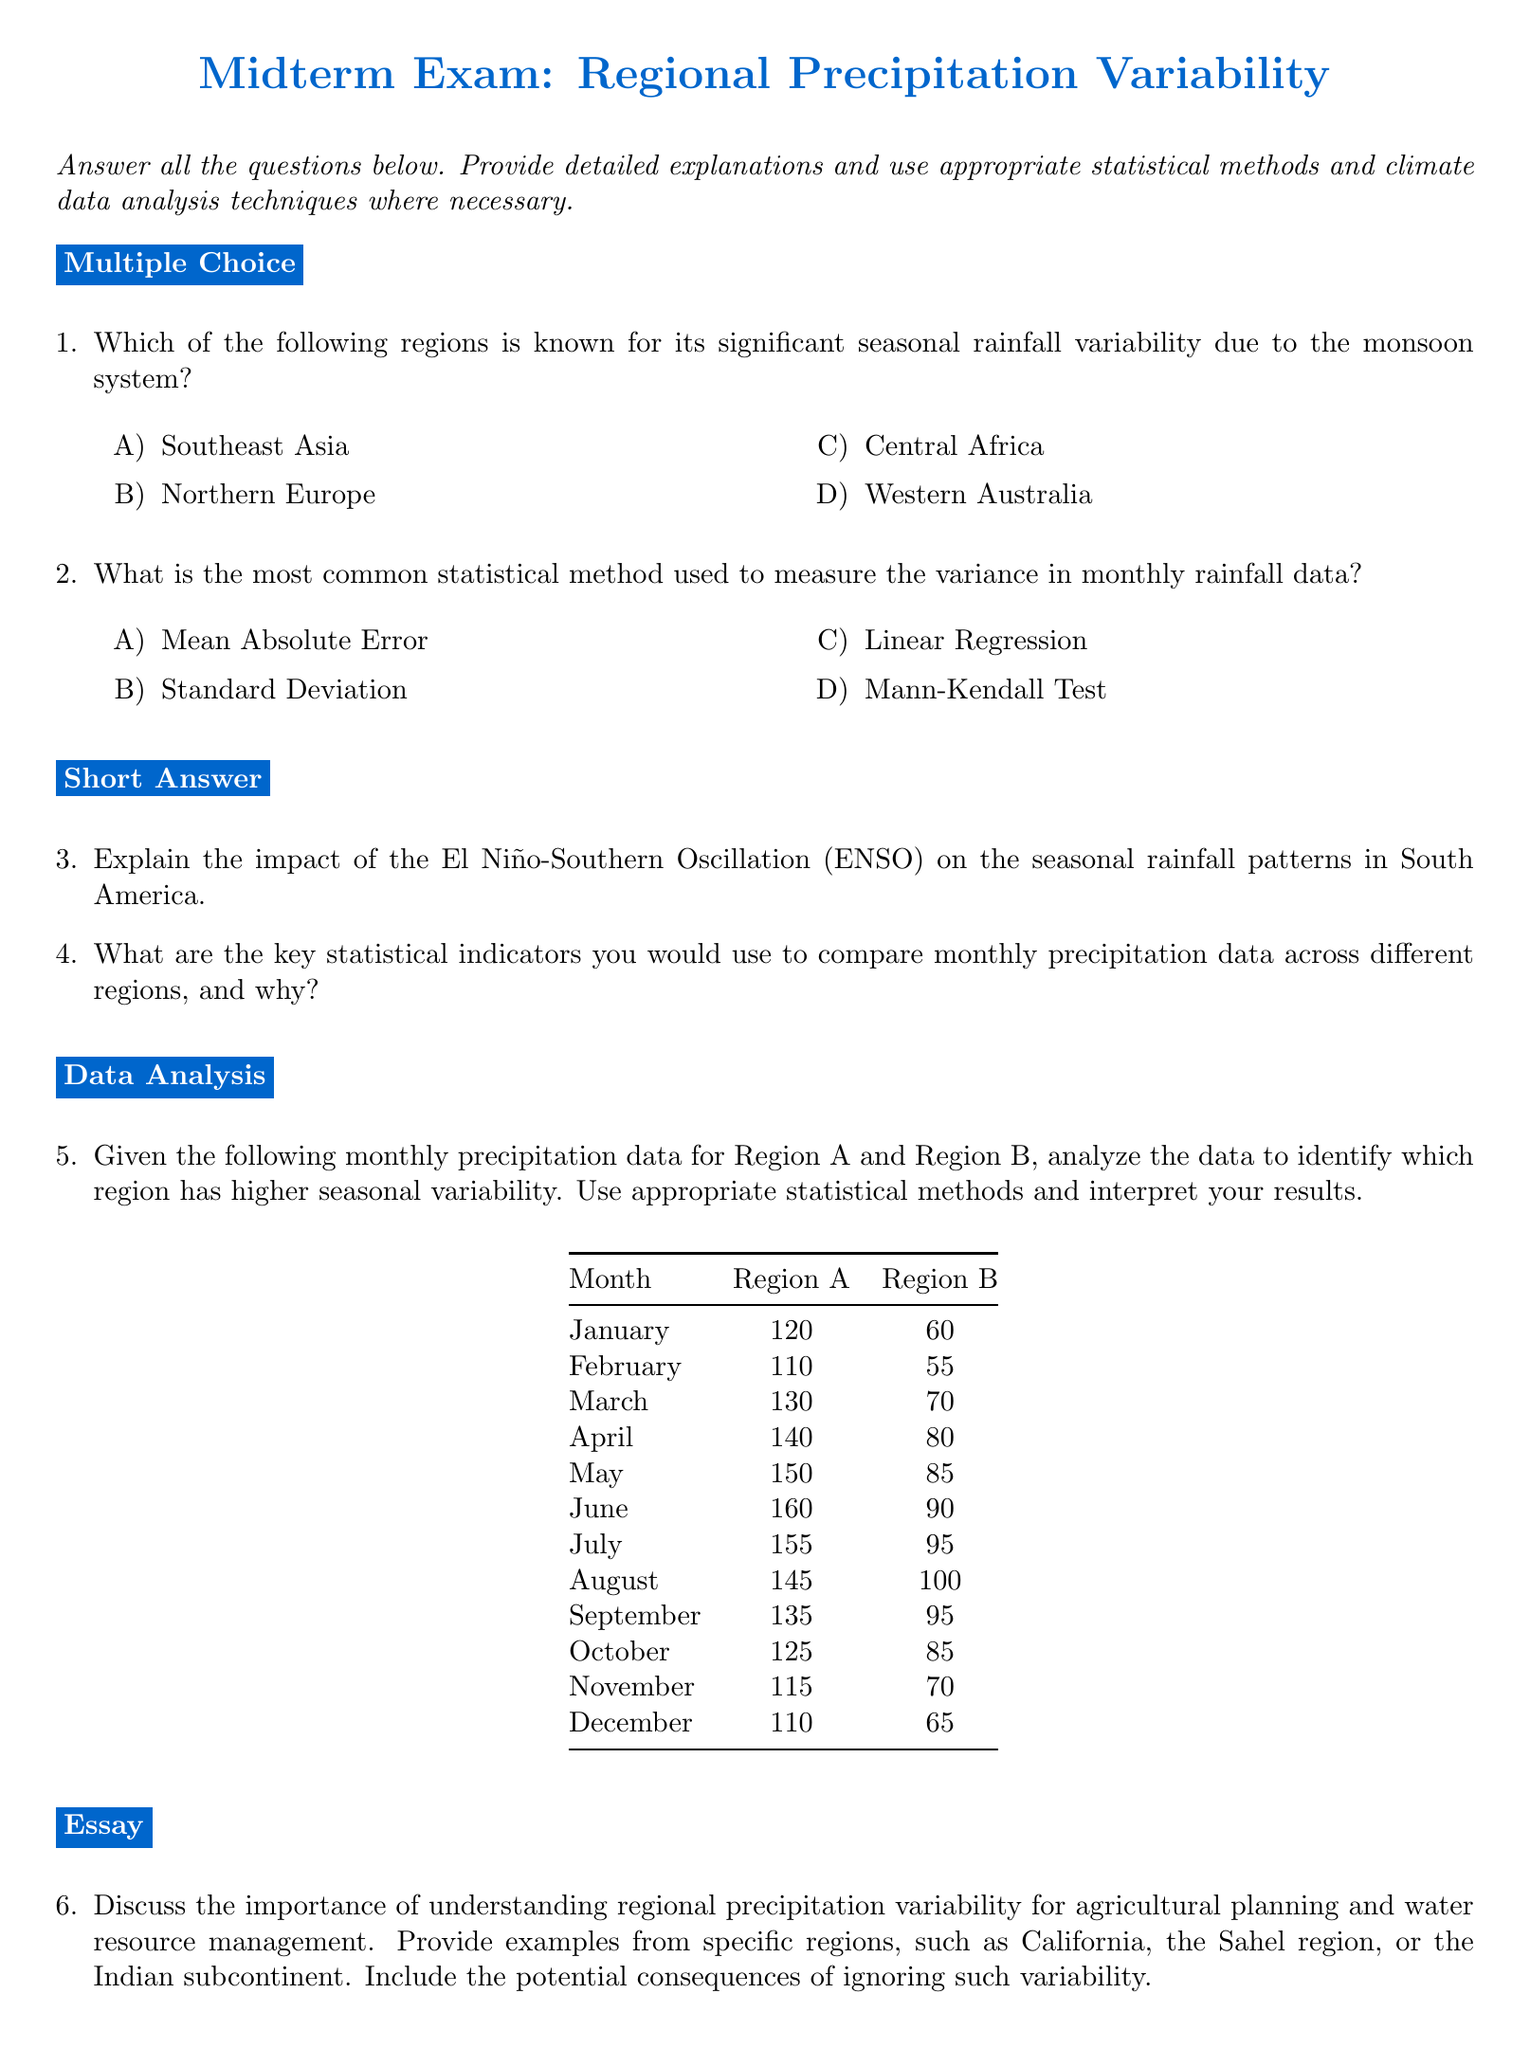What is the title of the midterm exam? The title is explicitly mentioned at the top of the document, which is related to regional precipitation variability.
Answer: Regional Precipitation Variability Which region is known for significant seasonal rainfall variability due to the monsoon system? The region that experiences notable variability from the monsoon system is listed in the multiple-choice section.
Answer: Southeast Asia What statistical method is commonly used to measure variance in monthly rainfall data? The most common method for variance measurement is provided in the multiple-choice section.
Answer: Standard Deviation What key indicators should be used to compare monthly precipitation data? The document invites a response for key statistical indicators, which typically involves standard metrics in climate data analysis.
Answer: Statistical indicators What months are included in the monthly precipitation data table? The months listed in the table span from January to December, as presented in the analysis section.
Answer: January, February, March, April, May, June, July, August, September, October, November, December What is the rainfall amount for Region A in April? The rainfall data for Region A in April can be directly found in the table.
Answer: 140 What is the purpose of the essay question? The purpose of the essay question is to discuss the significance of understanding precipitation variability regarding agricultural and water resource management.
Answer: To discuss significance Which specific regions are mentioned in the essay question for examples? The essay question provides examples of specific regions to illustrate the point.
Answer: California, Sahel region, Indian subcontinent What type of analysis is required for comparing regions A and B? The document specifies what kind of analysis should be conducted on the monthly precipitation data of the two regions.
Answer: Seasonal variability analysis 